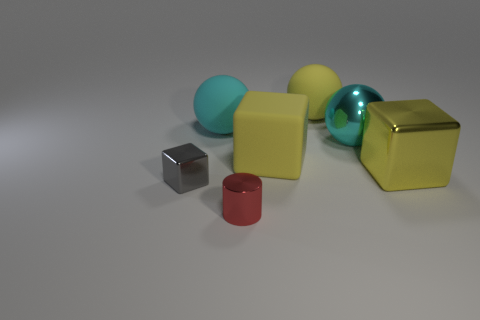There is a shiny thing that is both behind the cylinder and in front of the yellow shiny object; what is its shape?
Offer a terse response. Cube. There is a small cylinder; is it the same color as the metallic block that is behind the small gray cube?
Offer a terse response. No. There is a large matte thing in front of the shiny thing behind the big matte thing that is in front of the big cyan rubber object; what color is it?
Keep it short and to the point. Yellow. The other metallic object that is the same shape as the tiny gray metal object is what color?
Keep it short and to the point. Yellow. Are there an equal number of cyan metal spheres in front of the gray thing and small gray matte blocks?
Provide a succinct answer. Yes. How many balls are red objects or small metallic things?
Make the answer very short. 0. There is a ball that is the same material as the tiny red cylinder; what is its color?
Give a very brief answer. Cyan. Is the gray object made of the same material as the tiny object that is to the right of the cyan matte thing?
Give a very brief answer. Yes. How many objects are either gray objects or large cyan shiny objects?
Ensure brevity in your answer.  2. What is the material of the other large cube that is the same color as the large metallic cube?
Give a very brief answer. Rubber. 